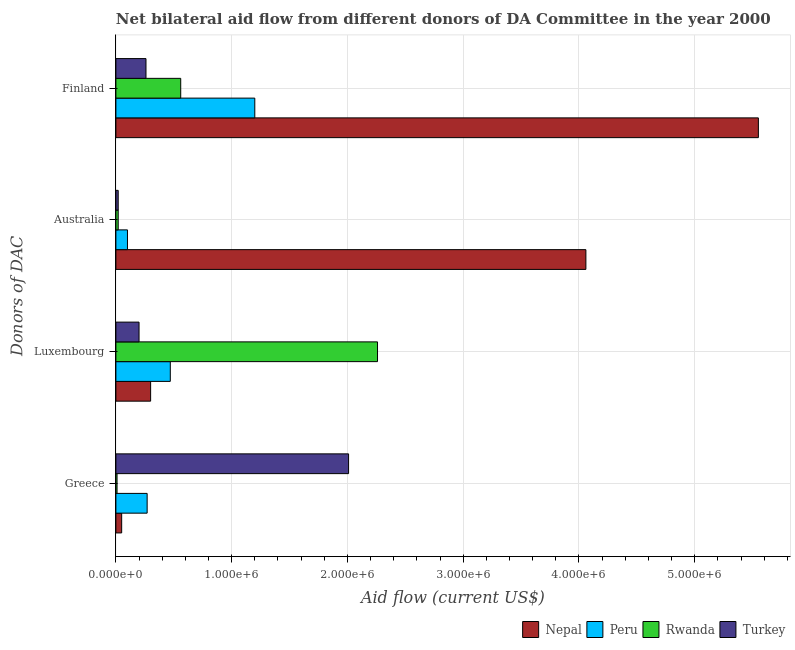How many groups of bars are there?
Offer a very short reply. 4. How many bars are there on the 1st tick from the top?
Offer a very short reply. 4. What is the label of the 3rd group of bars from the top?
Your response must be concise. Luxembourg. What is the amount of aid given by finland in Rwanda?
Offer a terse response. 5.60e+05. Across all countries, what is the maximum amount of aid given by greece?
Offer a terse response. 2.01e+06. Across all countries, what is the minimum amount of aid given by australia?
Your response must be concise. 2.00e+04. In which country was the amount of aid given by luxembourg maximum?
Offer a very short reply. Rwanda. What is the total amount of aid given by australia in the graph?
Provide a succinct answer. 4.20e+06. What is the difference between the amount of aid given by finland in Peru and that in Nepal?
Give a very brief answer. -4.35e+06. What is the difference between the amount of aid given by finland in Turkey and the amount of aid given by greece in Peru?
Make the answer very short. -10000. What is the average amount of aid given by australia per country?
Your response must be concise. 1.05e+06. What is the difference between the amount of aid given by luxembourg and amount of aid given by greece in Nepal?
Offer a very short reply. 2.50e+05. What is the ratio of the amount of aid given by australia in Peru to that in Nepal?
Ensure brevity in your answer.  0.02. Is the difference between the amount of aid given by australia in Peru and Turkey greater than the difference between the amount of aid given by luxembourg in Peru and Turkey?
Ensure brevity in your answer.  No. What is the difference between the highest and the second highest amount of aid given by finland?
Offer a very short reply. 4.35e+06. What is the difference between the highest and the lowest amount of aid given by luxembourg?
Provide a succinct answer. 2.06e+06. Is the sum of the amount of aid given by greece in Turkey and Peru greater than the maximum amount of aid given by finland across all countries?
Ensure brevity in your answer.  No. Is it the case that in every country, the sum of the amount of aid given by australia and amount of aid given by greece is greater than the sum of amount of aid given by finland and amount of aid given by luxembourg?
Offer a very short reply. No. Is it the case that in every country, the sum of the amount of aid given by greece and amount of aid given by luxembourg is greater than the amount of aid given by australia?
Your response must be concise. No. Does the graph contain any zero values?
Offer a terse response. No. Does the graph contain grids?
Your response must be concise. Yes. How many legend labels are there?
Provide a succinct answer. 4. What is the title of the graph?
Your response must be concise. Net bilateral aid flow from different donors of DA Committee in the year 2000. What is the label or title of the X-axis?
Make the answer very short. Aid flow (current US$). What is the label or title of the Y-axis?
Provide a short and direct response. Donors of DAC. What is the Aid flow (current US$) in Nepal in Greece?
Your answer should be compact. 5.00e+04. What is the Aid flow (current US$) of Peru in Greece?
Offer a very short reply. 2.70e+05. What is the Aid flow (current US$) in Rwanda in Greece?
Make the answer very short. 10000. What is the Aid flow (current US$) in Turkey in Greece?
Provide a short and direct response. 2.01e+06. What is the Aid flow (current US$) of Nepal in Luxembourg?
Offer a terse response. 3.00e+05. What is the Aid flow (current US$) of Rwanda in Luxembourg?
Ensure brevity in your answer.  2.26e+06. What is the Aid flow (current US$) of Nepal in Australia?
Keep it short and to the point. 4.06e+06. What is the Aid flow (current US$) in Rwanda in Australia?
Your answer should be very brief. 2.00e+04. What is the Aid flow (current US$) of Nepal in Finland?
Provide a succinct answer. 5.55e+06. What is the Aid flow (current US$) in Peru in Finland?
Your response must be concise. 1.20e+06. What is the Aid flow (current US$) in Rwanda in Finland?
Your answer should be very brief. 5.60e+05. What is the Aid flow (current US$) of Turkey in Finland?
Provide a succinct answer. 2.60e+05. Across all Donors of DAC, what is the maximum Aid flow (current US$) in Nepal?
Make the answer very short. 5.55e+06. Across all Donors of DAC, what is the maximum Aid flow (current US$) of Peru?
Give a very brief answer. 1.20e+06. Across all Donors of DAC, what is the maximum Aid flow (current US$) in Rwanda?
Offer a terse response. 2.26e+06. Across all Donors of DAC, what is the maximum Aid flow (current US$) in Turkey?
Make the answer very short. 2.01e+06. Across all Donors of DAC, what is the minimum Aid flow (current US$) in Nepal?
Give a very brief answer. 5.00e+04. Across all Donors of DAC, what is the minimum Aid flow (current US$) of Turkey?
Make the answer very short. 2.00e+04. What is the total Aid flow (current US$) of Nepal in the graph?
Your answer should be very brief. 9.96e+06. What is the total Aid flow (current US$) of Peru in the graph?
Offer a terse response. 2.04e+06. What is the total Aid flow (current US$) in Rwanda in the graph?
Make the answer very short. 2.85e+06. What is the total Aid flow (current US$) in Turkey in the graph?
Provide a short and direct response. 2.49e+06. What is the difference between the Aid flow (current US$) in Rwanda in Greece and that in Luxembourg?
Provide a succinct answer. -2.25e+06. What is the difference between the Aid flow (current US$) in Turkey in Greece and that in Luxembourg?
Offer a terse response. 1.81e+06. What is the difference between the Aid flow (current US$) in Nepal in Greece and that in Australia?
Your response must be concise. -4.01e+06. What is the difference between the Aid flow (current US$) in Rwanda in Greece and that in Australia?
Your answer should be compact. -10000. What is the difference between the Aid flow (current US$) in Turkey in Greece and that in Australia?
Provide a short and direct response. 1.99e+06. What is the difference between the Aid flow (current US$) in Nepal in Greece and that in Finland?
Offer a terse response. -5.50e+06. What is the difference between the Aid flow (current US$) of Peru in Greece and that in Finland?
Ensure brevity in your answer.  -9.30e+05. What is the difference between the Aid flow (current US$) in Rwanda in Greece and that in Finland?
Give a very brief answer. -5.50e+05. What is the difference between the Aid flow (current US$) in Turkey in Greece and that in Finland?
Your answer should be compact. 1.75e+06. What is the difference between the Aid flow (current US$) of Nepal in Luxembourg and that in Australia?
Your response must be concise. -3.76e+06. What is the difference between the Aid flow (current US$) in Rwanda in Luxembourg and that in Australia?
Keep it short and to the point. 2.24e+06. What is the difference between the Aid flow (current US$) in Turkey in Luxembourg and that in Australia?
Offer a terse response. 1.80e+05. What is the difference between the Aid flow (current US$) in Nepal in Luxembourg and that in Finland?
Provide a succinct answer. -5.25e+06. What is the difference between the Aid flow (current US$) of Peru in Luxembourg and that in Finland?
Make the answer very short. -7.30e+05. What is the difference between the Aid flow (current US$) of Rwanda in Luxembourg and that in Finland?
Give a very brief answer. 1.70e+06. What is the difference between the Aid flow (current US$) in Turkey in Luxembourg and that in Finland?
Keep it short and to the point. -6.00e+04. What is the difference between the Aid flow (current US$) in Nepal in Australia and that in Finland?
Ensure brevity in your answer.  -1.49e+06. What is the difference between the Aid flow (current US$) of Peru in Australia and that in Finland?
Make the answer very short. -1.10e+06. What is the difference between the Aid flow (current US$) in Rwanda in Australia and that in Finland?
Give a very brief answer. -5.40e+05. What is the difference between the Aid flow (current US$) of Turkey in Australia and that in Finland?
Keep it short and to the point. -2.40e+05. What is the difference between the Aid flow (current US$) in Nepal in Greece and the Aid flow (current US$) in Peru in Luxembourg?
Ensure brevity in your answer.  -4.20e+05. What is the difference between the Aid flow (current US$) of Nepal in Greece and the Aid flow (current US$) of Rwanda in Luxembourg?
Offer a very short reply. -2.21e+06. What is the difference between the Aid flow (current US$) of Peru in Greece and the Aid flow (current US$) of Rwanda in Luxembourg?
Offer a very short reply. -1.99e+06. What is the difference between the Aid flow (current US$) in Peru in Greece and the Aid flow (current US$) in Turkey in Luxembourg?
Make the answer very short. 7.00e+04. What is the difference between the Aid flow (current US$) of Rwanda in Greece and the Aid flow (current US$) of Turkey in Luxembourg?
Provide a succinct answer. -1.90e+05. What is the difference between the Aid flow (current US$) of Nepal in Greece and the Aid flow (current US$) of Turkey in Australia?
Offer a terse response. 3.00e+04. What is the difference between the Aid flow (current US$) in Peru in Greece and the Aid flow (current US$) in Rwanda in Australia?
Make the answer very short. 2.50e+05. What is the difference between the Aid flow (current US$) of Nepal in Greece and the Aid flow (current US$) of Peru in Finland?
Your response must be concise. -1.15e+06. What is the difference between the Aid flow (current US$) of Nepal in Greece and the Aid flow (current US$) of Rwanda in Finland?
Your answer should be very brief. -5.10e+05. What is the difference between the Aid flow (current US$) in Nepal in Greece and the Aid flow (current US$) in Turkey in Finland?
Your answer should be compact. -2.10e+05. What is the difference between the Aid flow (current US$) in Peru in Greece and the Aid flow (current US$) in Rwanda in Finland?
Keep it short and to the point. -2.90e+05. What is the difference between the Aid flow (current US$) in Nepal in Luxembourg and the Aid flow (current US$) in Peru in Australia?
Provide a succinct answer. 2.00e+05. What is the difference between the Aid flow (current US$) in Nepal in Luxembourg and the Aid flow (current US$) in Rwanda in Australia?
Your answer should be very brief. 2.80e+05. What is the difference between the Aid flow (current US$) in Rwanda in Luxembourg and the Aid flow (current US$) in Turkey in Australia?
Offer a terse response. 2.24e+06. What is the difference between the Aid flow (current US$) in Nepal in Luxembourg and the Aid flow (current US$) in Peru in Finland?
Give a very brief answer. -9.00e+05. What is the difference between the Aid flow (current US$) in Nepal in Luxembourg and the Aid flow (current US$) in Turkey in Finland?
Make the answer very short. 4.00e+04. What is the difference between the Aid flow (current US$) in Peru in Luxembourg and the Aid flow (current US$) in Turkey in Finland?
Your answer should be very brief. 2.10e+05. What is the difference between the Aid flow (current US$) in Rwanda in Luxembourg and the Aid flow (current US$) in Turkey in Finland?
Keep it short and to the point. 2.00e+06. What is the difference between the Aid flow (current US$) of Nepal in Australia and the Aid flow (current US$) of Peru in Finland?
Your response must be concise. 2.86e+06. What is the difference between the Aid flow (current US$) of Nepal in Australia and the Aid flow (current US$) of Rwanda in Finland?
Provide a succinct answer. 3.50e+06. What is the difference between the Aid flow (current US$) in Nepal in Australia and the Aid flow (current US$) in Turkey in Finland?
Your answer should be very brief. 3.80e+06. What is the difference between the Aid flow (current US$) in Peru in Australia and the Aid flow (current US$) in Rwanda in Finland?
Offer a terse response. -4.60e+05. What is the difference between the Aid flow (current US$) of Peru in Australia and the Aid flow (current US$) of Turkey in Finland?
Keep it short and to the point. -1.60e+05. What is the average Aid flow (current US$) in Nepal per Donors of DAC?
Your answer should be compact. 2.49e+06. What is the average Aid flow (current US$) of Peru per Donors of DAC?
Your response must be concise. 5.10e+05. What is the average Aid flow (current US$) in Rwanda per Donors of DAC?
Provide a succinct answer. 7.12e+05. What is the average Aid flow (current US$) in Turkey per Donors of DAC?
Ensure brevity in your answer.  6.22e+05. What is the difference between the Aid flow (current US$) in Nepal and Aid flow (current US$) in Peru in Greece?
Your answer should be compact. -2.20e+05. What is the difference between the Aid flow (current US$) in Nepal and Aid flow (current US$) in Rwanda in Greece?
Give a very brief answer. 4.00e+04. What is the difference between the Aid flow (current US$) of Nepal and Aid flow (current US$) of Turkey in Greece?
Ensure brevity in your answer.  -1.96e+06. What is the difference between the Aid flow (current US$) of Peru and Aid flow (current US$) of Turkey in Greece?
Make the answer very short. -1.74e+06. What is the difference between the Aid flow (current US$) in Rwanda and Aid flow (current US$) in Turkey in Greece?
Your answer should be very brief. -2.00e+06. What is the difference between the Aid flow (current US$) in Nepal and Aid flow (current US$) in Rwanda in Luxembourg?
Offer a very short reply. -1.96e+06. What is the difference between the Aid flow (current US$) in Nepal and Aid flow (current US$) in Turkey in Luxembourg?
Provide a succinct answer. 1.00e+05. What is the difference between the Aid flow (current US$) in Peru and Aid flow (current US$) in Rwanda in Luxembourg?
Offer a terse response. -1.79e+06. What is the difference between the Aid flow (current US$) in Rwanda and Aid flow (current US$) in Turkey in Luxembourg?
Ensure brevity in your answer.  2.06e+06. What is the difference between the Aid flow (current US$) in Nepal and Aid flow (current US$) in Peru in Australia?
Offer a very short reply. 3.96e+06. What is the difference between the Aid flow (current US$) of Nepal and Aid flow (current US$) of Rwanda in Australia?
Provide a short and direct response. 4.04e+06. What is the difference between the Aid flow (current US$) in Nepal and Aid flow (current US$) in Turkey in Australia?
Offer a very short reply. 4.04e+06. What is the difference between the Aid flow (current US$) of Peru and Aid flow (current US$) of Rwanda in Australia?
Your response must be concise. 8.00e+04. What is the difference between the Aid flow (current US$) in Peru and Aid flow (current US$) in Turkey in Australia?
Your answer should be compact. 8.00e+04. What is the difference between the Aid flow (current US$) of Nepal and Aid flow (current US$) of Peru in Finland?
Give a very brief answer. 4.35e+06. What is the difference between the Aid flow (current US$) in Nepal and Aid flow (current US$) in Rwanda in Finland?
Ensure brevity in your answer.  4.99e+06. What is the difference between the Aid flow (current US$) in Nepal and Aid flow (current US$) in Turkey in Finland?
Provide a succinct answer. 5.29e+06. What is the difference between the Aid flow (current US$) of Peru and Aid flow (current US$) of Rwanda in Finland?
Give a very brief answer. 6.40e+05. What is the difference between the Aid flow (current US$) of Peru and Aid flow (current US$) of Turkey in Finland?
Provide a succinct answer. 9.40e+05. What is the ratio of the Aid flow (current US$) of Peru in Greece to that in Luxembourg?
Your response must be concise. 0.57. What is the ratio of the Aid flow (current US$) of Rwanda in Greece to that in Luxembourg?
Give a very brief answer. 0. What is the ratio of the Aid flow (current US$) of Turkey in Greece to that in Luxembourg?
Offer a very short reply. 10.05. What is the ratio of the Aid flow (current US$) in Nepal in Greece to that in Australia?
Your answer should be compact. 0.01. What is the ratio of the Aid flow (current US$) in Turkey in Greece to that in Australia?
Your answer should be very brief. 100.5. What is the ratio of the Aid flow (current US$) of Nepal in Greece to that in Finland?
Offer a terse response. 0.01. What is the ratio of the Aid flow (current US$) of Peru in Greece to that in Finland?
Your answer should be very brief. 0.23. What is the ratio of the Aid flow (current US$) of Rwanda in Greece to that in Finland?
Offer a terse response. 0.02. What is the ratio of the Aid flow (current US$) of Turkey in Greece to that in Finland?
Provide a succinct answer. 7.73. What is the ratio of the Aid flow (current US$) in Nepal in Luxembourg to that in Australia?
Your answer should be very brief. 0.07. What is the ratio of the Aid flow (current US$) in Rwanda in Luxembourg to that in Australia?
Your response must be concise. 113. What is the ratio of the Aid flow (current US$) in Turkey in Luxembourg to that in Australia?
Your answer should be very brief. 10. What is the ratio of the Aid flow (current US$) of Nepal in Luxembourg to that in Finland?
Keep it short and to the point. 0.05. What is the ratio of the Aid flow (current US$) of Peru in Luxembourg to that in Finland?
Offer a terse response. 0.39. What is the ratio of the Aid flow (current US$) of Rwanda in Luxembourg to that in Finland?
Provide a short and direct response. 4.04. What is the ratio of the Aid flow (current US$) in Turkey in Luxembourg to that in Finland?
Your response must be concise. 0.77. What is the ratio of the Aid flow (current US$) in Nepal in Australia to that in Finland?
Your answer should be compact. 0.73. What is the ratio of the Aid flow (current US$) in Peru in Australia to that in Finland?
Your answer should be compact. 0.08. What is the ratio of the Aid flow (current US$) in Rwanda in Australia to that in Finland?
Your response must be concise. 0.04. What is the ratio of the Aid flow (current US$) in Turkey in Australia to that in Finland?
Keep it short and to the point. 0.08. What is the difference between the highest and the second highest Aid flow (current US$) of Nepal?
Give a very brief answer. 1.49e+06. What is the difference between the highest and the second highest Aid flow (current US$) of Peru?
Ensure brevity in your answer.  7.30e+05. What is the difference between the highest and the second highest Aid flow (current US$) in Rwanda?
Your answer should be very brief. 1.70e+06. What is the difference between the highest and the second highest Aid flow (current US$) in Turkey?
Offer a terse response. 1.75e+06. What is the difference between the highest and the lowest Aid flow (current US$) in Nepal?
Ensure brevity in your answer.  5.50e+06. What is the difference between the highest and the lowest Aid flow (current US$) of Peru?
Offer a terse response. 1.10e+06. What is the difference between the highest and the lowest Aid flow (current US$) in Rwanda?
Offer a terse response. 2.25e+06. What is the difference between the highest and the lowest Aid flow (current US$) of Turkey?
Your answer should be compact. 1.99e+06. 